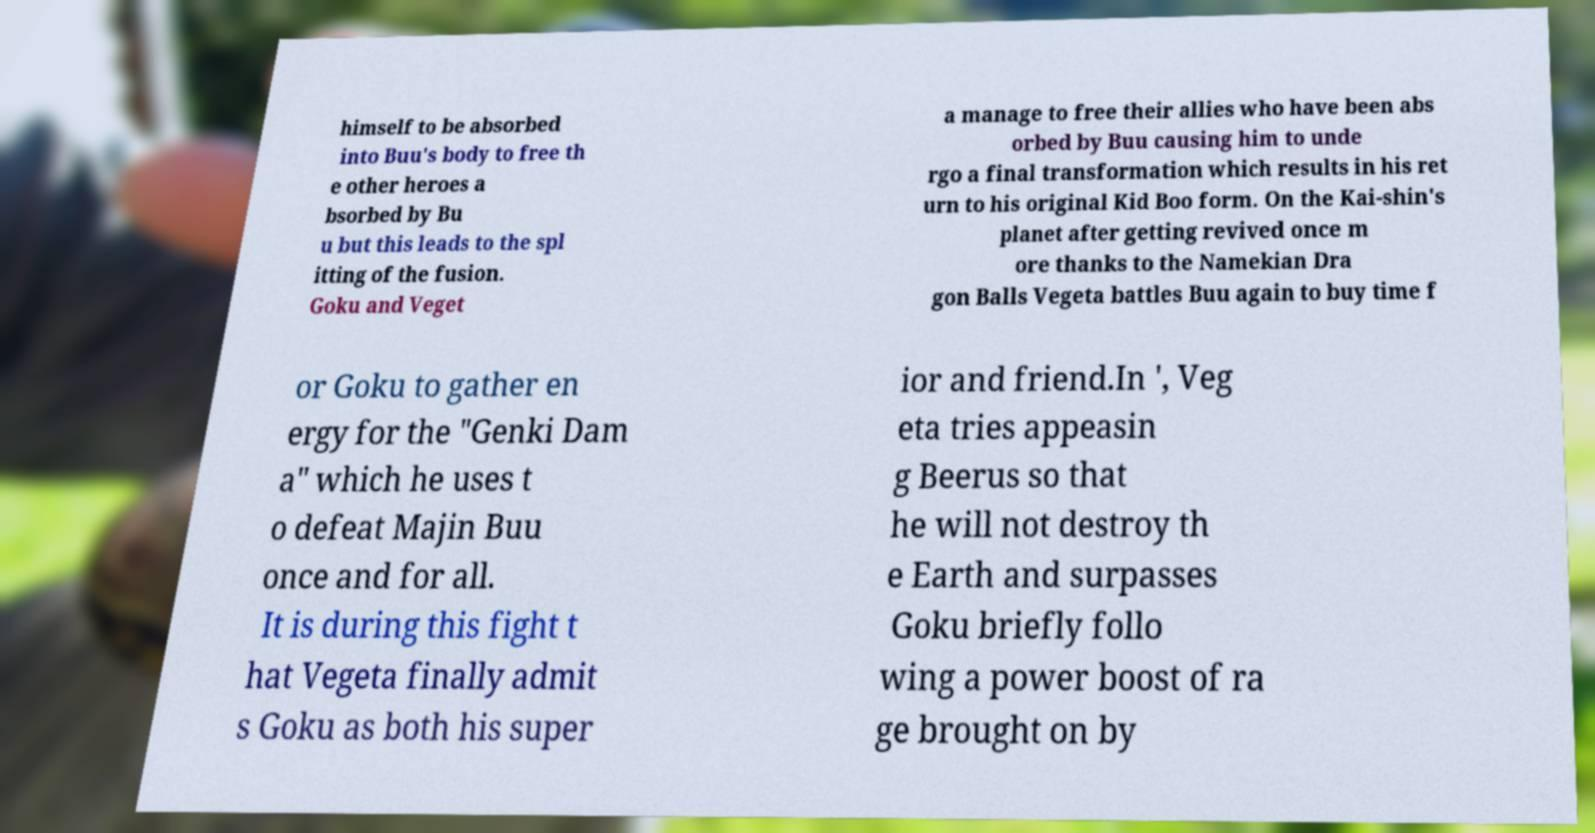There's text embedded in this image that I need extracted. Can you transcribe it verbatim? himself to be absorbed into Buu's body to free th e other heroes a bsorbed by Bu u but this leads to the spl itting of the fusion. Goku and Veget a manage to free their allies who have been abs orbed by Buu causing him to unde rgo a final transformation which results in his ret urn to his original Kid Boo form. On the Kai-shin's planet after getting revived once m ore thanks to the Namekian Dra gon Balls Vegeta battles Buu again to buy time f or Goku to gather en ergy for the "Genki Dam a" which he uses t o defeat Majin Buu once and for all. It is during this fight t hat Vegeta finally admit s Goku as both his super ior and friend.In ', Veg eta tries appeasin g Beerus so that he will not destroy th e Earth and surpasses Goku briefly follo wing a power boost of ra ge brought on by 